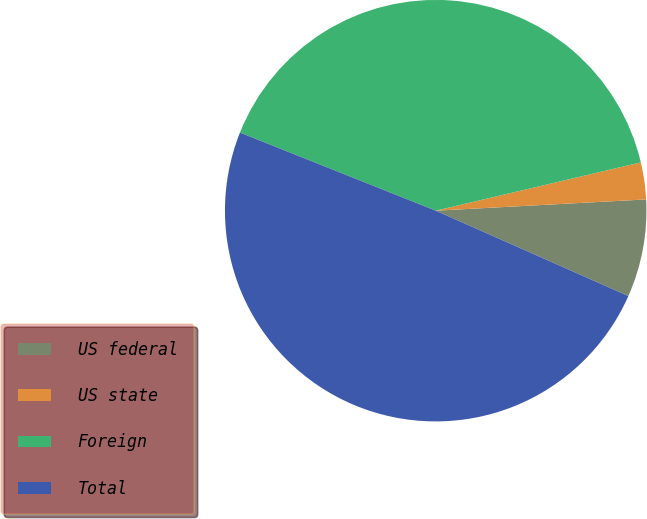Convert chart. <chart><loc_0><loc_0><loc_500><loc_500><pie_chart><fcel>US federal<fcel>US state<fcel>Foreign<fcel>Total<nl><fcel>7.49%<fcel>2.83%<fcel>40.28%<fcel>49.4%<nl></chart> 